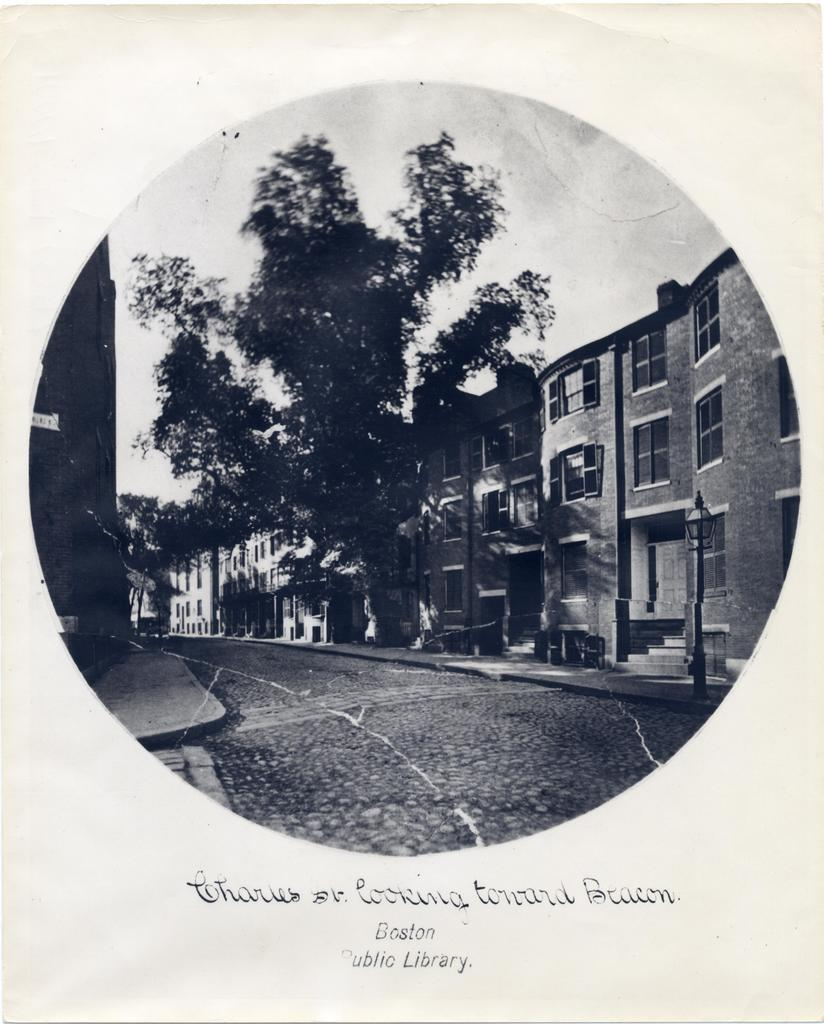What type of structures can be seen in the image? There are buildings in the image. What other natural elements are present in the image? There are trees in the image. What can be used for transportation in the image? There is a road in the image. What is visible in the background of the image? The sky is visible in the image. What type of text can be seen at the bottom of the image? There is some text on a paper at the bottom of the image. How does the spoon blow the leaves off the trees in the image? There is no spoon present in the image, and therefore no such action can be observed. 